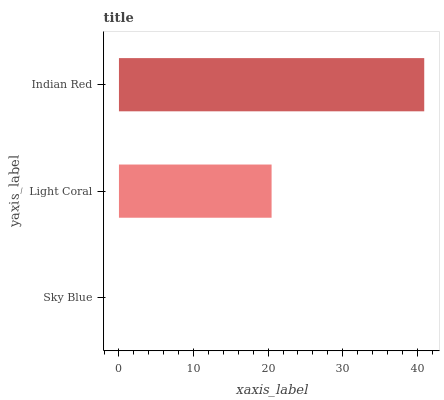Is Sky Blue the minimum?
Answer yes or no. Yes. Is Indian Red the maximum?
Answer yes or no. Yes. Is Light Coral the minimum?
Answer yes or no. No. Is Light Coral the maximum?
Answer yes or no. No. Is Light Coral greater than Sky Blue?
Answer yes or no. Yes. Is Sky Blue less than Light Coral?
Answer yes or no. Yes. Is Sky Blue greater than Light Coral?
Answer yes or no. No. Is Light Coral less than Sky Blue?
Answer yes or no. No. Is Light Coral the high median?
Answer yes or no. Yes. Is Light Coral the low median?
Answer yes or no. Yes. Is Indian Red the high median?
Answer yes or no. No. Is Sky Blue the low median?
Answer yes or no. No. 